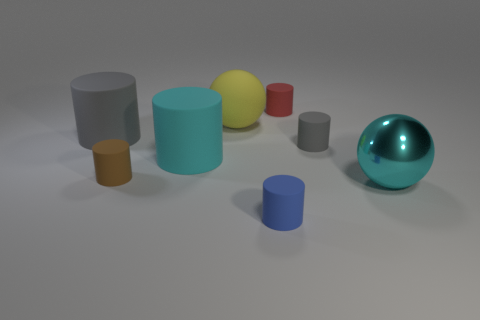Subtract 2 cylinders. How many cylinders are left? 4 Subtract all red cylinders. How many cylinders are left? 5 Subtract all red matte cylinders. How many cylinders are left? 5 Subtract all blue cylinders. Subtract all yellow balls. How many cylinders are left? 5 Add 2 small brown shiny cubes. How many objects exist? 10 Subtract all cylinders. How many objects are left? 2 Subtract all tiny green metal spheres. Subtract all red objects. How many objects are left? 7 Add 4 small matte things. How many small matte things are left? 8 Add 8 big cyan rubber things. How many big cyan rubber things exist? 9 Subtract 0 purple cylinders. How many objects are left? 8 